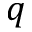<formula> <loc_0><loc_0><loc_500><loc_500>q</formula> 